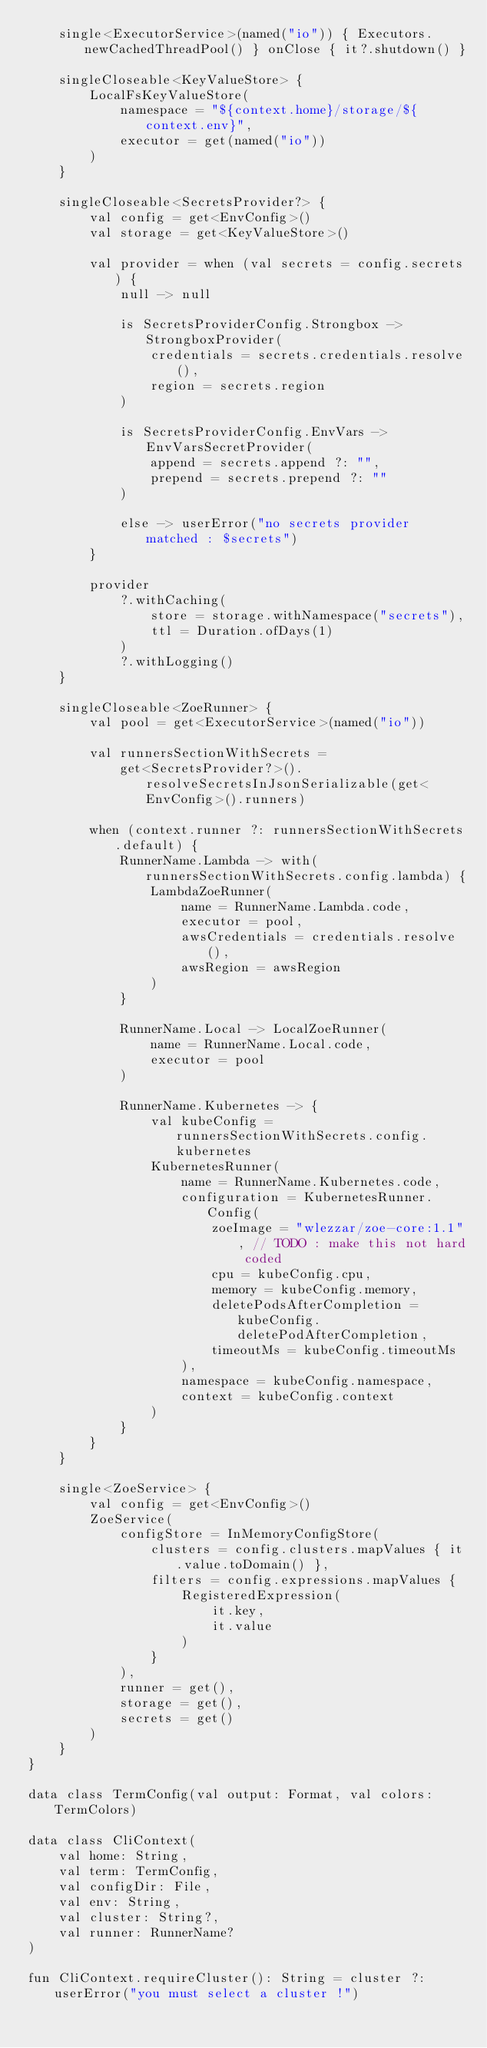Convert code to text. <code><loc_0><loc_0><loc_500><loc_500><_Kotlin_>    single<ExecutorService>(named("io")) { Executors.newCachedThreadPool() } onClose { it?.shutdown() }

    singleCloseable<KeyValueStore> {
        LocalFsKeyValueStore(
            namespace = "${context.home}/storage/${context.env}",
            executor = get(named("io"))
        )
    }

    singleCloseable<SecretsProvider?> {
        val config = get<EnvConfig>()
        val storage = get<KeyValueStore>()

        val provider = when (val secrets = config.secrets) {
            null -> null

            is SecretsProviderConfig.Strongbox -> StrongboxProvider(
                credentials = secrets.credentials.resolve(),
                region = secrets.region
            )

            is SecretsProviderConfig.EnvVars -> EnvVarsSecretProvider(
                append = secrets.append ?: "",
                prepend = secrets.prepend ?: ""
            )

            else -> userError("no secrets provider matched : $secrets")
        }

        provider
            ?.withCaching(
                store = storage.withNamespace("secrets"),
                ttl = Duration.ofDays(1)
            )
            ?.withLogging()
    }

    singleCloseable<ZoeRunner> {
        val pool = get<ExecutorService>(named("io"))

        val runnersSectionWithSecrets =
            get<SecretsProvider?>().resolveSecretsInJsonSerializable(get<EnvConfig>().runners)

        when (context.runner ?: runnersSectionWithSecrets.default) {
            RunnerName.Lambda -> with(runnersSectionWithSecrets.config.lambda) {
                LambdaZoeRunner(
                    name = RunnerName.Lambda.code,
                    executor = pool,
                    awsCredentials = credentials.resolve(),
                    awsRegion = awsRegion
                )
            }

            RunnerName.Local -> LocalZoeRunner(
                name = RunnerName.Local.code,
                executor = pool
            )

            RunnerName.Kubernetes -> {
                val kubeConfig = runnersSectionWithSecrets.config.kubernetes
                KubernetesRunner(
                    name = RunnerName.Kubernetes.code,
                    configuration = KubernetesRunner.Config(
                        zoeImage = "wlezzar/zoe-core:1.1", // TODO : make this not hard coded
                        cpu = kubeConfig.cpu,
                        memory = kubeConfig.memory,
                        deletePodsAfterCompletion = kubeConfig.deletePodAfterCompletion,
                        timeoutMs = kubeConfig.timeoutMs
                    ),
                    namespace = kubeConfig.namespace,
                    context = kubeConfig.context
                )
            }
        }
    }

    single<ZoeService> {
        val config = get<EnvConfig>()
        ZoeService(
            configStore = InMemoryConfigStore(
                clusters = config.clusters.mapValues { it.value.toDomain() },
                filters = config.expressions.mapValues {
                    RegisteredExpression(
                        it.key,
                        it.value
                    )
                }
            ),
            runner = get(),
            storage = get(),
            secrets = get()
        )
    }
}

data class TermConfig(val output: Format, val colors: TermColors)

data class CliContext(
    val home: String,
    val term: TermConfig,
    val configDir: File,
    val env: String,
    val cluster: String?,
    val runner: RunnerName?
)

fun CliContext.requireCluster(): String = cluster ?: userError("you must select a cluster !")
</code> 